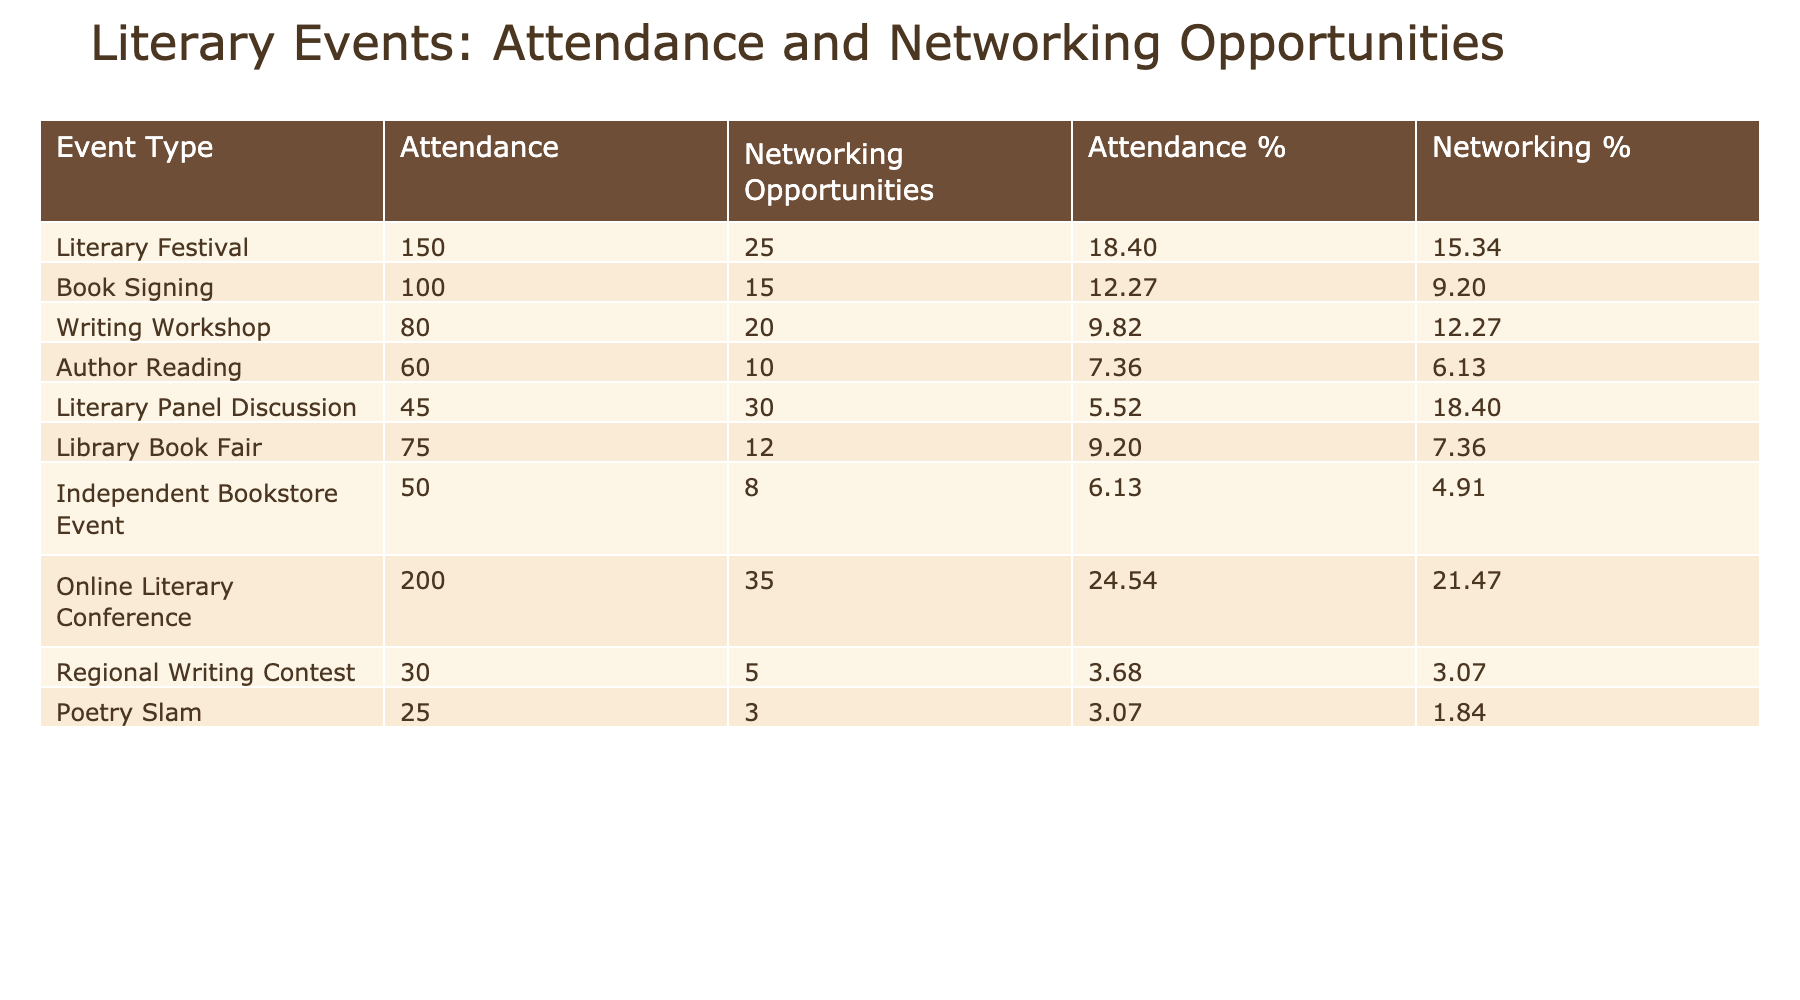What is the total attendance for all events combined? To find the total attendance, we need to sum the attendance figures for each event type: 150 + 100 + 80 + 60 + 45 + 75 + 50 + 200 + 30 + 25 = 915.
Answer: 915 Which event had the highest number of networking opportunities gained? Looking at the 'Networking Opportunities Gained' column, the highest number is 35 from the 'Online Literary Conference.'
Answer: Online Literary Conference What percentage of the total attendance was from literary festivals? The attendance for literary festivals is 150. To find the percentage, we use the formula (Attendance / Total Attendance) * 100, which is (150 / 915) * 100 ≈ 16.38%.
Answer: Approximately 16.38% What is the average number of networking opportunities gained across all events? To find the average, we sum the 'Networking Opportunities Gained' column: 25 + 15 + 20 + 10 + 30 + 12 + 8 + 35 + 5 + 3 = 163. There are 10 events, so the average is 163 / 10 = 16.3.
Answer: 16.3 Is the number of networking opportunities gained at a literary panel discussion greater than the average? The average networking opportunities gained is 16.3, and for the literary panel discussion, it is 30. Since 30 is greater than 16.3, the answer is yes.
Answer: Yes What is the difference in networking opportunities gained between an author reading and a writing workshop? The author reading has 10 networking opportunities and the writing workshop has 20. So the difference is 20 - 10 = 10.
Answer: 10 Which event type contributed the least to the total attendance? By analyzing the 'Attendance' column, the 'Poetry Slam' has the least attendance of 25, less than all other events listed.
Answer: Poetry Slam How many events had more than 20 networking opportunities gained? We assess how many entries in the 'Networking Opportunities Gained' exceed 20. These events are: Literary Festival (25), Writing Workshop (20), Literary Panel Discussion (30), Online Literary Conference (35), totaling 4 events.
Answer: 4 Did the Library Book Fair gain more networking opportunities than the Independent Bookstore Event? The Library Book Fair had 12 networking opportunities, while the Independent Bookstore Event had 8. As 12 is greater than 8, the answer is yes.
Answer: Yes 